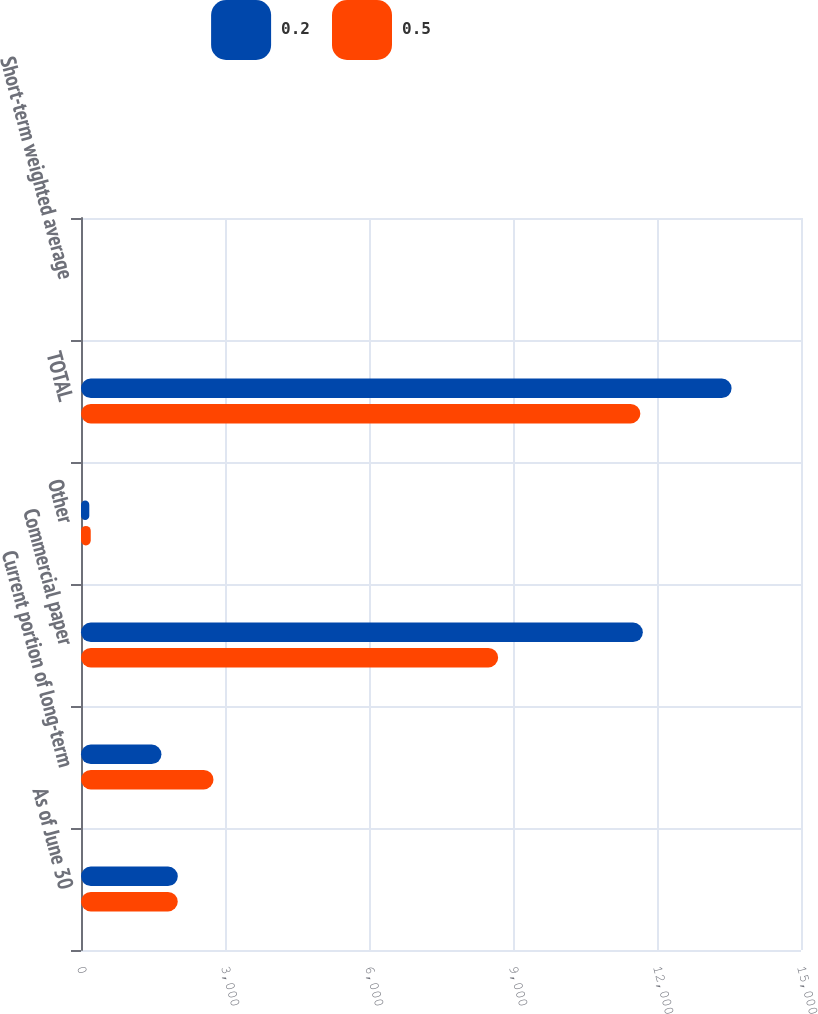<chart> <loc_0><loc_0><loc_500><loc_500><stacked_bar_chart><ecel><fcel>As of June 30<fcel>Current portion of long-term<fcel>Commercial paper<fcel>Other<fcel>TOTAL<fcel>Short-term weighted average<nl><fcel>0.2<fcel>2017<fcel>1676<fcel>11705<fcel>173<fcel>13554<fcel>0.5<nl><fcel>0.5<fcel>2016<fcel>2760<fcel>8690<fcel>203<fcel>11653<fcel>0.2<nl></chart> 